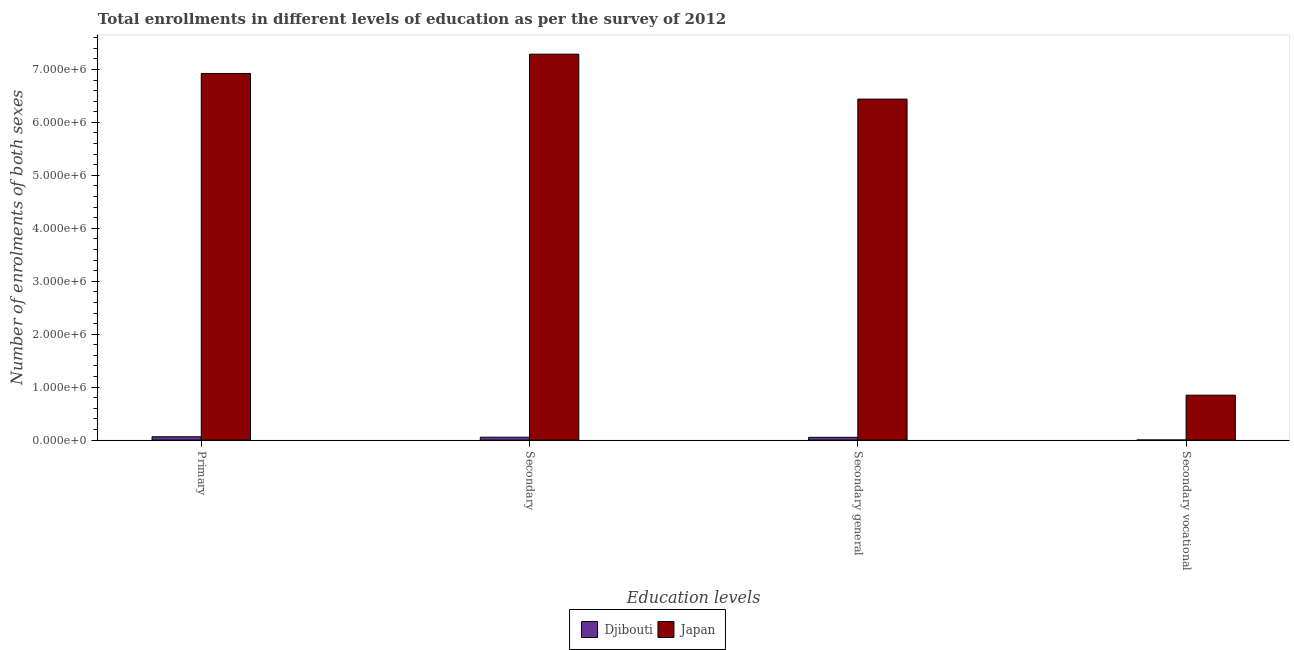How many different coloured bars are there?
Your response must be concise. 2. How many groups of bars are there?
Give a very brief answer. 4. How many bars are there on the 4th tick from the right?
Provide a succinct answer. 2. What is the label of the 2nd group of bars from the left?
Make the answer very short. Secondary. What is the number of enrolments in secondary general education in Djibouti?
Provide a succinct answer. 5.28e+04. Across all countries, what is the maximum number of enrolments in secondary vocational education?
Offer a terse response. 8.48e+05. Across all countries, what is the minimum number of enrolments in secondary vocational education?
Ensure brevity in your answer.  2289. In which country was the number of enrolments in secondary general education minimum?
Offer a terse response. Djibouti. What is the total number of enrolments in secondary general education in the graph?
Ensure brevity in your answer.  6.49e+06. What is the difference between the number of enrolments in secondary general education in Japan and that in Djibouti?
Offer a terse response. 6.39e+06. What is the difference between the number of enrolments in secondary vocational education in Djibouti and the number of enrolments in secondary education in Japan?
Offer a very short reply. -7.29e+06. What is the average number of enrolments in primary education per country?
Offer a very short reply. 3.49e+06. What is the difference between the number of enrolments in secondary education and number of enrolments in secondary general education in Djibouti?
Provide a succinct answer. 2289. In how many countries, is the number of enrolments in primary education greater than 600000 ?
Provide a short and direct response. 1. What is the ratio of the number of enrolments in primary education in Djibouti to that in Japan?
Your answer should be compact. 0.01. Is the difference between the number of enrolments in secondary general education in Japan and Djibouti greater than the difference between the number of enrolments in secondary education in Japan and Djibouti?
Your answer should be very brief. No. What is the difference between the highest and the second highest number of enrolments in secondary vocational education?
Keep it short and to the point. 8.46e+05. What is the difference between the highest and the lowest number of enrolments in primary education?
Keep it short and to the point. 6.86e+06. In how many countries, is the number of enrolments in secondary education greater than the average number of enrolments in secondary education taken over all countries?
Offer a very short reply. 1. Is the sum of the number of enrolments in secondary vocational education in Japan and Djibouti greater than the maximum number of enrolments in secondary education across all countries?
Your answer should be compact. No. Is it the case that in every country, the sum of the number of enrolments in primary education and number of enrolments in secondary general education is greater than the sum of number of enrolments in secondary education and number of enrolments in secondary vocational education?
Keep it short and to the point. No. What does the 1st bar from the right in Secondary general represents?
Give a very brief answer. Japan. Is it the case that in every country, the sum of the number of enrolments in primary education and number of enrolments in secondary education is greater than the number of enrolments in secondary general education?
Your answer should be very brief. Yes. How many bars are there?
Provide a succinct answer. 8. Are all the bars in the graph horizontal?
Ensure brevity in your answer.  No. How many countries are there in the graph?
Provide a succinct answer. 2. Are the values on the major ticks of Y-axis written in scientific E-notation?
Ensure brevity in your answer.  Yes. Does the graph contain any zero values?
Ensure brevity in your answer.  No. Where does the legend appear in the graph?
Keep it short and to the point. Bottom center. How many legend labels are there?
Offer a very short reply. 2. How are the legend labels stacked?
Make the answer very short. Horizontal. What is the title of the graph?
Give a very brief answer. Total enrollments in different levels of education as per the survey of 2012. What is the label or title of the X-axis?
Keep it short and to the point. Education levels. What is the label or title of the Y-axis?
Give a very brief answer. Number of enrolments of both sexes. What is the Number of enrolments of both sexes in Djibouti in Primary?
Keep it short and to the point. 6.36e+04. What is the Number of enrolments of both sexes in Japan in Primary?
Provide a succinct answer. 6.92e+06. What is the Number of enrolments of both sexes of Djibouti in Secondary?
Offer a very short reply. 5.51e+04. What is the Number of enrolments of both sexes of Japan in Secondary?
Offer a very short reply. 7.29e+06. What is the Number of enrolments of both sexes in Djibouti in Secondary general?
Give a very brief answer. 5.28e+04. What is the Number of enrolments of both sexes in Japan in Secondary general?
Give a very brief answer. 6.44e+06. What is the Number of enrolments of both sexes of Djibouti in Secondary vocational?
Ensure brevity in your answer.  2289. What is the Number of enrolments of both sexes of Japan in Secondary vocational?
Offer a very short reply. 8.48e+05. Across all Education levels, what is the maximum Number of enrolments of both sexes in Djibouti?
Give a very brief answer. 6.36e+04. Across all Education levels, what is the maximum Number of enrolments of both sexes of Japan?
Offer a terse response. 7.29e+06. Across all Education levels, what is the minimum Number of enrolments of both sexes of Djibouti?
Keep it short and to the point. 2289. Across all Education levels, what is the minimum Number of enrolments of both sexes of Japan?
Your answer should be very brief. 8.48e+05. What is the total Number of enrolments of both sexes of Djibouti in the graph?
Give a very brief answer. 1.74e+05. What is the total Number of enrolments of both sexes in Japan in the graph?
Provide a short and direct response. 2.15e+07. What is the difference between the Number of enrolments of both sexes of Djibouti in Primary and that in Secondary?
Provide a succinct answer. 8530. What is the difference between the Number of enrolments of both sexes of Japan in Primary and that in Secondary?
Your response must be concise. -3.64e+05. What is the difference between the Number of enrolments of both sexes in Djibouti in Primary and that in Secondary general?
Make the answer very short. 1.08e+04. What is the difference between the Number of enrolments of both sexes of Japan in Primary and that in Secondary general?
Offer a terse response. 4.84e+05. What is the difference between the Number of enrolments of both sexes in Djibouti in Primary and that in Secondary vocational?
Ensure brevity in your answer.  6.13e+04. What is the difference between the Number of enrolments of both sexes of Japan in Primary and that in Secondary vocational?
Offer a terse response. 6.08e+06. What is the difference between the Number of enrolments of both sexes in Djibouti in Secondary and that in Secondary general?
Your response must be concise. 2289. What is the difference between the Number of enrolments of both sexes in Japan in Secondary and that in Secondary general?
Give a very brief answer. 8.48e+05. What is the difference between the Number of enrolments of both sexes in Djibouti in Secondary and that in Secondary vocational?
Your response must be concise. 5.28e+04. What is the difference between the Number of enrolments of both sexes in Japan in Secondary and that in Secondary vocational?
Keep it short and to the point. 6.44e+06. What is the difference between the Number of enrolments of both sexes in Djibouti in Secondary general and that in Secondary vocational?
Your response must be concise. 5.05e+04. What is the difference between the Number of enrolments of both sexes in Japan in Secondary general and that in Secondary vocational?
Make the answer very short. 5.59e+06. What is the difference between the Number of enrolments of both sexes of Djibouti in Primary and the Number of enrolments of both sexes of Japan in Secondary?
Provide a short and direct response. -7.22e+06. What is the difference between the Number of enrolments of both sexes in Djibouti in Primary and the Number of enrolments of both sexes in Japan in Secondary general?
Give a very brief answer. -6.38e+06. What is the difference between the Number of enrolments of both sexes in Djibouti in Primary and the Number of enrolments of both sexes in Japan in Secondary vocational?
Your answer should be compact. -7.85e+05. What is the difference between the Number of enrolments of both sexes in Djibouti in Secondary and the Number of enrolments of both sexes in Japan in Secondary general?
Make the answer very short. -6.38e+06. What is the difference between the Number of enrolments of both sexes of Djibouti in Secondary and the Number of enrolments of both sexes of Japan in Secondary vocational?
Your answer should be very brief. -7.93e+05. What is the difference between the Number of enrolments of both sexes of Djibouti in Secondary general and the Number of enrolments of both sexes of Japan in Secondary vocational?
Your answer should be compact. -7.96e+05. What is the average Number of enrolments of both sexes of Djibouti per Education levels?
Provide a succinct answer. 4.34e+04. What is the average Number of enrolments of both sexes of Japan per Education levels?
Your answer should be compact. 5.38e+06. What is the difference between the Number of enrolments of both sexes in Djibouti and Number of enrolments of both sexes in Japan in Primary?
Keep it short and to the point. -6.86e+06. What is the difference between the Number of enrolments of both sexes in Djibouti and Number of enrolments of both sexes in Japan in Secondary?
Your response must be concise. -7.23e+06. What is the difference between the Number of enrolments of both sexes in Djibouti and Number of enrolments of both sexes in Japan in Secondary general?
Make the answer very short. -6.39e+06. What is the difference between the Number of enrolments of both sexes in Djibouti and Number of enrolments of both sexes in Japan in Secondary vocational?
Give a very brief answer. -8.46e+05. What is the ratio of the Number of enrolments of both sexes in Djibouti in Primary to that in Secondary?
Ensure brevity in your answer.  1.15. What is the ratio of the Number of enrolments of both sexes of Japan in Primary to that in Secondary?
Your answer should be compact. 0.95. What is the ratio of the Number of enrolments of both sexes in Djibouti in Primary to that in Secondary general?
Provide a short and direct response. 1.2. What is the ratio of the Number of enrolments of both sexes in Japan in Primary to that in Secondary general?
Your answer should be very brief. 1.08. What is the ratio of the Number of enrolments of both sexes in Djibouti in Primary to that in Secondary vocational?
Your answer should be compact. 27.79. What is the ratio of the Number of enrolments of both sexes of Japan in Primary to that in Secondary vocational?
Your response must be concise. 8.16. What is the ratio of the Number of enrolments of both sexes in Djibouti in Secondary to that in Secondary general?
Your answer should be compact. 1.04. What is the ratio of the Number of enrolments of both sexes of Japan in Secondary to that in Secondary general?
Your answer should be compact. 1.13. What is the ratio of the Number of enrolments of both sexes in Djibouti in Secondary to that in Secondary vocational?
Ensure brevity in your answer.  24.06. What is the ratio of the Number of enrolments of both sexes of Japan in Secondary to that in Secondary vocational?
Keep it short and to the point. 8.59. What is the ratio of the Number of enrolments of both sexes of Djibouti in Secondary general to that in Secondary vocational?
Offer a terse response. 23.06. What is the ratio of the Number of enrolments of both sexes in Japan in Secondary general to that in Secondary vocational?
Ensure brevity in your answer.  7.59. What is the difference between the highest and the second highest Number of enrolments of both sexes in Djibouti?
Ensure brevity in your answer.  8530. What is the difference between the highest and the second highest Number of enrolments of both sexes in Japan?
Ensure brevity in your answer.  3.64e+05. What is the difference between the highest and the lowest Number of enrolments of both sexes of Djibouti?
Your answer should be compact. 6.13e+04. What is the difference between the highest and the lowest Number of enrolments of both sexes of Japan?
Keep it short and to the point. 6.44e+06. 